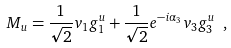<formula> <loc_0><loc_0><loc_500><loc_500>M _ { u } = \frac { 1 } { \sqrt { 2 } } v _ { 1 } g _ { 1 } ^ { u } + \frac { 1 } { \sqrt { 2 } } e ^ { - i \alpha _ { 3 } } v _ { 3 } g _ { 3 } ^ { u } \ ,</formula> 